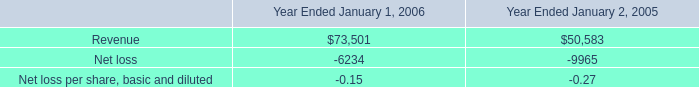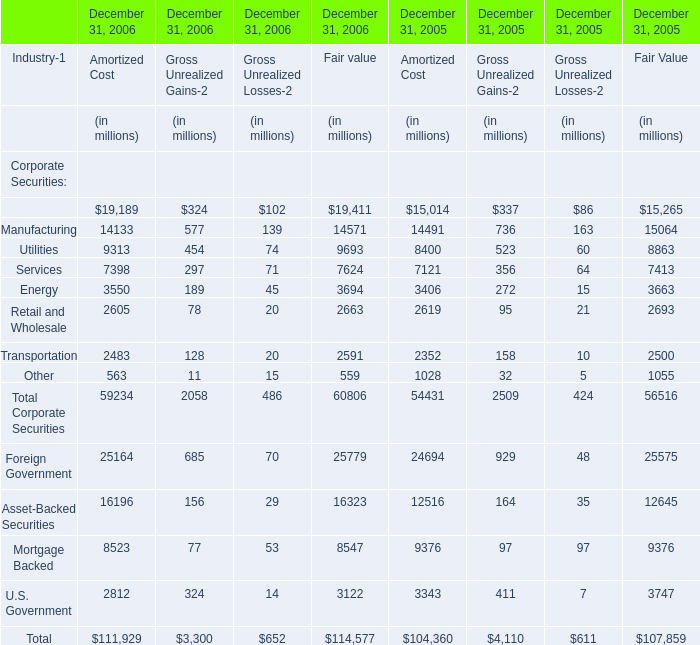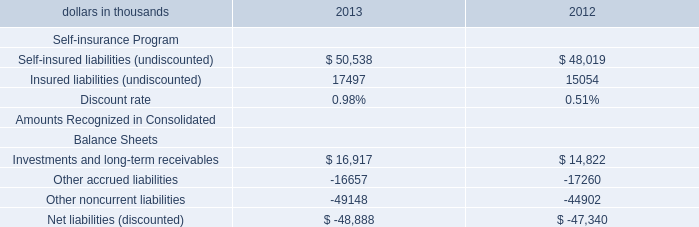What was the total amount of the Transportation in the years where Finance greater than 0? (in million) 
Computations: (((((((2483 + 128) + 20) + 2591) + 2352) + 158) + 10) + 2500)
Answer: 10242.0. 